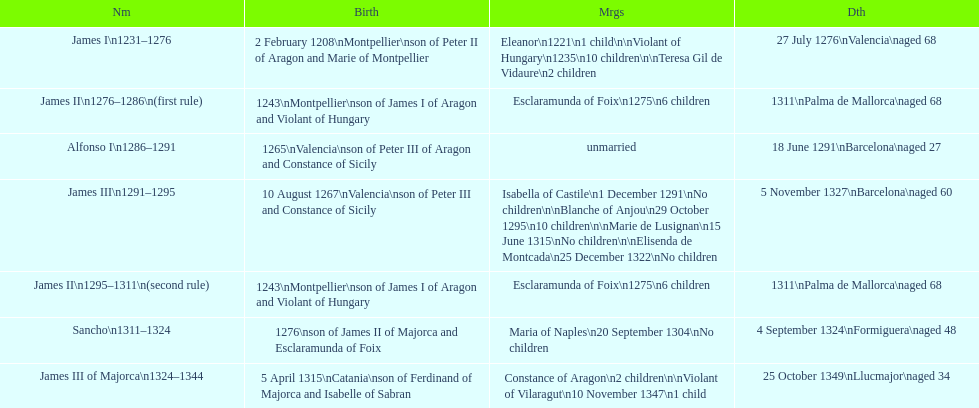Which monarch is listed first? James I 1231-1276. I'm looking to parse the entire table for insights. Could you assist me with that? {'header': ['Nm', 'Birth', 'Mrgs', 'Dth'], 'rows': [['James I\\n1231–1276', '2 February 1208\\nMontpellier\\nson of Peter II of Aragon and Marie of Montpellier', 'Eleanor\\n1221\\n1 child\\n\\nViolant of Hungary\\n1235\\n10 children\\n\\nTeresa Gil de Vidaure\\n2 children', '27 July 1276\\nValencia\\naged 68'], ['James II\\n1276–1286\\n(first rule)', '1243\\nMontpellier\\nson of James I of Aragon and Violant of Hungary', 'Esclaramunda of Foix\\n1275\\n6 children', '1311\\nPalma de Mallorca\\naged 68'], ['Alfonso I\\n1286–1291', '1265\\nValencia\\nson of Peter III of Aragon and Constance of Sicily', 'unmarried', '18 June 1291\\nBarcelona\\naged 27'], ['James III\\n1291–1295', '10 August 1267\\nValencia\\nson of Peter III and Constance of Sicily', 'Isabella of Castile\\n1 December 1291\\nNo children\\n\\nBlanche of Anjou\\n29 October 1295\\n10 children\\n\\nMarie de Lusignan\\n15 June 1315\\nNo children\\n\\nElisenda de Montcada\\n25 December 1322\\nNo children', '5 November 1327\\nBarcelona\\naged 60'], ['James II\\n1295–1311\\n(second rule)', '1243\\nMontpellier\\nson of James I of Aragon and Violant of Hungary', 'Esclaramunda of Foix\\n1275\\n6 children', '1311\\nPalma de Mallorca\\naged 68'], ['Sancho\\n1311–1324', '1276\\nson of James II of Majorca and Esclaramunda of Foix', 'Maria of Naples\\n20 September 1304\\nNo children', '4 September 1324\\nFormiguera\\naged 48'], ['James III of Majorca\\n1324–1344', '5 April 1315\\nCatania\\nson of Ferdinand of Majorca and Isabelle of Sabran', 'Constance of Aragon\\n2 children\\n\\nViolant of Vilaragut\\n10 November 1347\\n1 child', '25 October 1349\\nLlucmajor\\naged 34']]} 